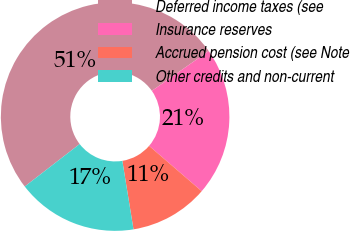Convert chart. <chart><loc_0><loc_0><loc_500><loc_500><pie_chart><fcel>Deferred income taxes (see<fcel>Insurance reserves<fcel>Accrued pension cost (see Note<fcel>Other credits and non-current<nl><fcel>50.75%<fcel>21.05%<fcel>11.11%<fcel>17.09%<nl></chart> 